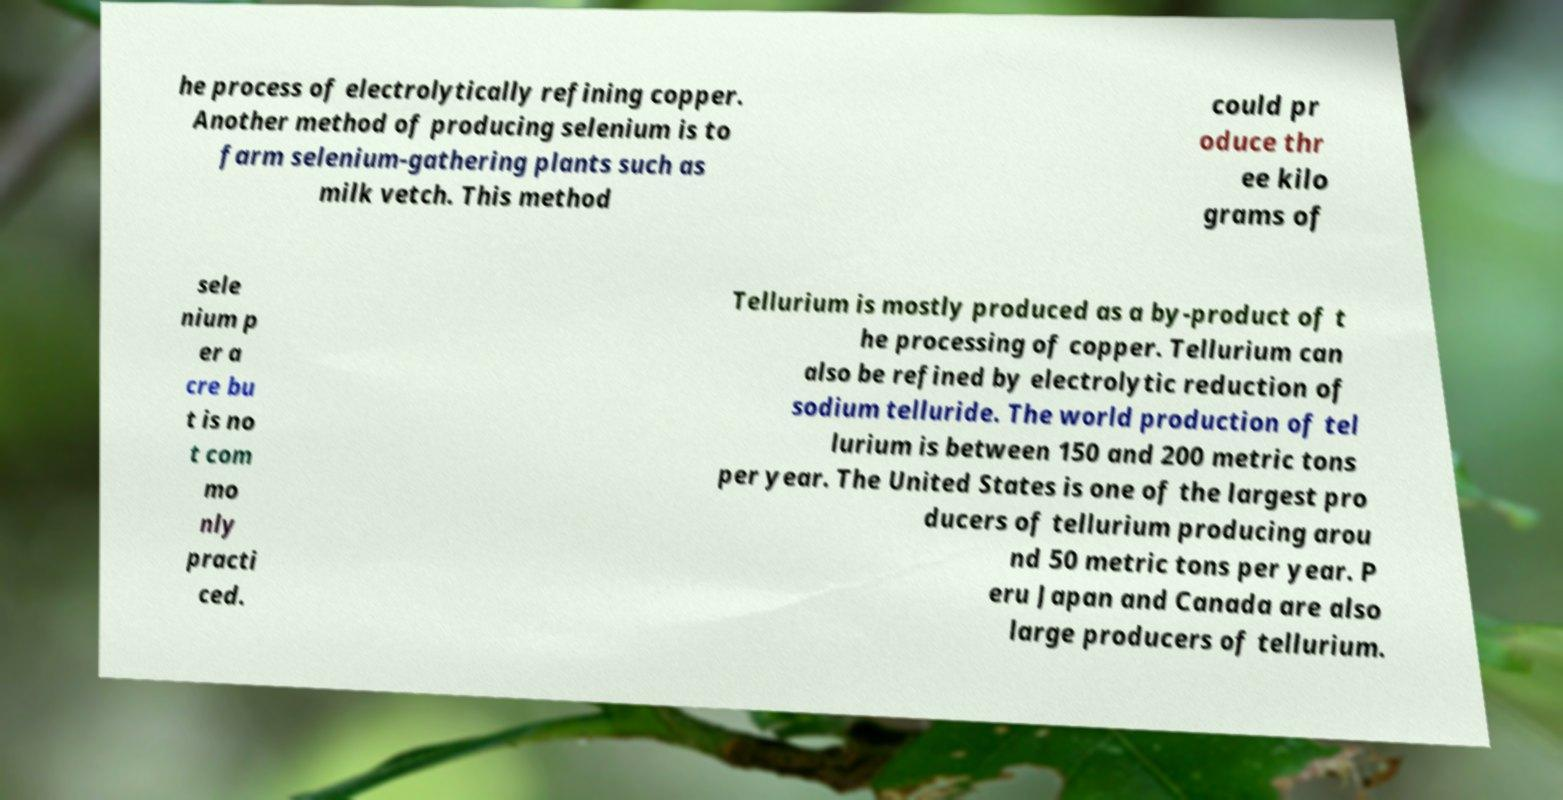I need the written content from this picture converted into text. Can you do that? he process of electrolytically refining copper. Another method of producing selenium is to farm selenium-gathering plants such as milk vetch. This method could pr oduce thr ee kilo grams of sele nium p er a cre bu t is no t com mo nly practi ced. Tellurium is mostly produced as a by-product of t he processing of copper. Tellurium can also be refined by electrolytic reduction of sodium telluride. The world production of tel lurium is between 150 and 200 metric tons per year. The United States is one of the largest pro ducers of tellurium producing arou nd 50 metric tons per year. P eru Japan and Canada are also large producers of tellurium. 